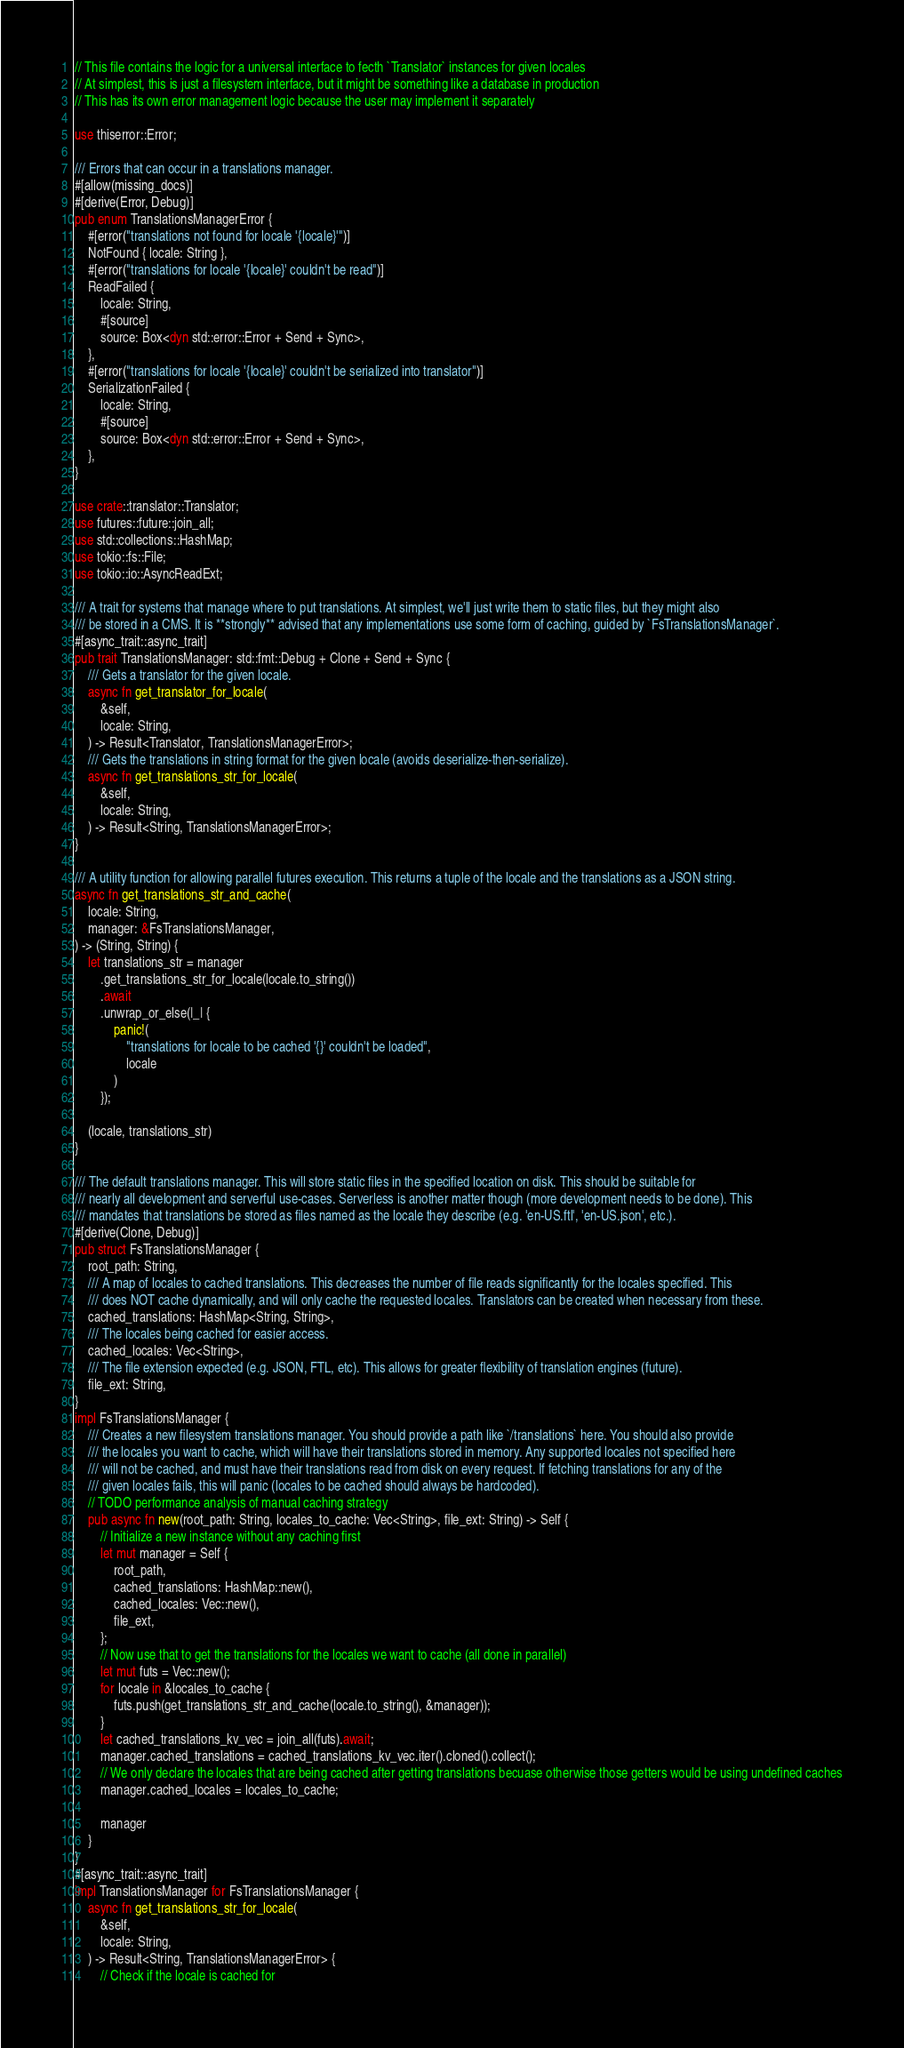Convert code to text. <code><loc_0><loc_0><loc_500><loc_500><_Rust_>// This file contains the logic for a universal interface to fecth `Translator` instances for given locales
// At simplest, this is just a filesystem interface, but it might be something like a database in production
// This has its own error management logic because the user may implement it separately

use thiserror::Error;

/// Errors that can occur in a translations manager.
#[allow(missing_docs)]
#[derive(Error, Debug)]
pub enum TranslationsManagerError {
    #[error("translations not found for locale '{locale}'")]
    NotFound { locale: String },
    #[error("translations for locale '{locale}' couldn't be read")]
    ReadFailed {
        locale: String,
        #[source]
        source: Box<dyn std::error::Error + Send + Sync>,
    },
    #[error("translations for locale '{locale}' couldn't be serialized into translator")]
    SerializationFailed {
        locale: String,
        #[source]
        source: Box<dyn std::error::Error + Send + Sync>,
    },
}

use crate::translator::Translator;
use futures::future::join_all;
use std::collections::HashMap;
use tokio::fs::File;
use tokio::io::AsyncReadExt;

/// A trait for systems that manage where to put translations. At simplest, we'll just write them to static files, but they might also
/// be stored in a CMS. It is **strongly** advised that any implementations use some form of caching, guided by `FsTranslationsManager`.
#[async_trait::async_trait]
pub trait TranslationsManager: std::fmt::Debug + Clone + Send + Sync {
    /// Gets a translator for the given locale.
    async fn get_translator_for_locale(
        &self,
        locale: String,
    ) -> Result<Translator, TranslationsManagerError>;
    /// Gets the translations in string format for the given locale (avoids deserialize-then-serialize).
    async fn get_translations_str_for_locale(
        &self,
        locale: String,
    ) -> Result<String, TranslationsManagerError>;
}

/// A utility function for allowing parallel futures execution. This returns a tuple of the locale and the translations as a JSON string.
async fn get_translations_str_and_cache(
    locale: String,
    manager: &FsTranslationsManager,
) -> (String, String) {
    let translations_str = manager
        .get_translations_str_for_locale(locale.to_string())
        .await
        .unwrap_or_else(|_| {
            panic!(
                "translations for locale to be cached '{}' couldn't be loaded",
                locale
            )
        });

    (locale, translations_str)
}

/// The default translations manager. This will store static files in the specified location on disk. This should be suitable for
/// nearly all development and serverful use-cases. Serverless is another matter though (more development needs to be done). This
/// mandates that translations be stored as files named as the locale they describe (e.g. 'en-US.ftl', 'en-US.json', etc.).
#[derive(Clone, Debug)]
pub struct FsTranslationsManager {
    root_path: String,
    /// A map of locales to cached translations. This decreases the number of file reads significantly for the locales specified. This
    /// does NOT cache dynamically, and will only cache the requested locales. Translators can be created when necessary from these.
    cached_translations: HashMap<String, String>,
    /// The locales being cached for easier access.
    cached_locales: Vec<String>,
    /// The file extension expected (e.g. JSON, FTL, etc). This allows for greater flexibility of translation engines (future).
    file_ext: String,
}
impl FsTranslationsManager {
    /// Creates a new filesystem translations manager. You should provide a path like `/translations` here. You should also provide
    /// the locales you want to cache, which will have their translations stored in memory. Any supported locales not specified here
    /// will not be cached, and must have their translations read from disk on every request. If fetching translations for any of the
    /// given locales fails, this will panic (locales to be cached should always be hardcoded).
    // TODO performance analysis of manual caching strategy
    pub async fn new(root_path: String, locales_to_cache: Vec<String>, file_ext: String) -> Self {
        // Initialize a new instance without any caching first
        let mut manager = Self {
            root_path,
            cached_translations: HashMap::new(),
            cached_locales: Vec::new(),
            file_ext,
        };
        // Now use that to get the translations for the locales we want to cache (all done in parallel)
        let mut futs = Vec::new();
        for locale in &locales_to_cache {
            futs.push(get_translations_str_and_cache(locale.to_string(), &manager));
        }
        let cached_translations_kv_vec = join_all(futs).await;
        manager.cached_translations = cached_translations_kv_vec.iter().cloned().collect();
        // We only declare the locales that are being cached after getting translations becuase otherwise those getters would be using undefined caches
        manager.cached_locales = locales_to_cache;

        manager
    }
}
#[async_trait::async_trait]
impl TranslationsManager for FsTranslationsManager {
    async fn get_translations_str_for_locale(
        &self,
        locale: String,
    ) -> Result<String, TranslationsManagerError> {
        // Check if the locale is cached for</code> 